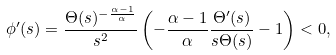Convert formula to latex. <formula><loc_0><loc_0><loc_500><loc_500>\phi ^ { \prime } ( s ) = \frac { \Theta ( s ) ^ { - \frac { \alpha - 1 } { \alpha } } } { s ^ { 2 } } \left ( - \frac { \alpha - 1 } { \alpha } \frac { \Theta ^ { \prime } ( s ) } { s \Theta ( s ) } - 1 \right ) < 0 ,</formula> 